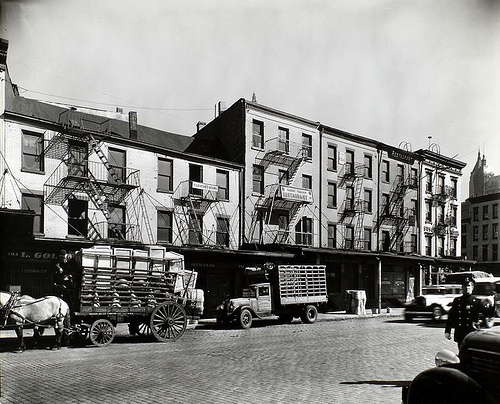Describe the objects in this image and their specific colors. I can see truck in black, darkgray, gray, and lightgray tones, car in black, gray, darkgray, and lightgray tones, horse in black, lightgray, darkgray, and gray tones, truck in black, white, gray, and darkgray tones, and people in black, gray, lightgray, and darkgray tones in this image. 